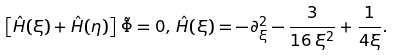<formula> <loc_0><loc_0><loc_500><loc_500>\left [ \hat { H } ( \xi ) + \hat { H } ( \eta ) \right ] \, \tilde { \Phi } = 0 , \, \hat { H } ( \xi ) = - \partial ^ { 2 } _ { \xi } - \frac { 3 } { 1 6 \, \xi ^ { 2 } } + \frac { 1 } { 4 \xi } .</formula> 